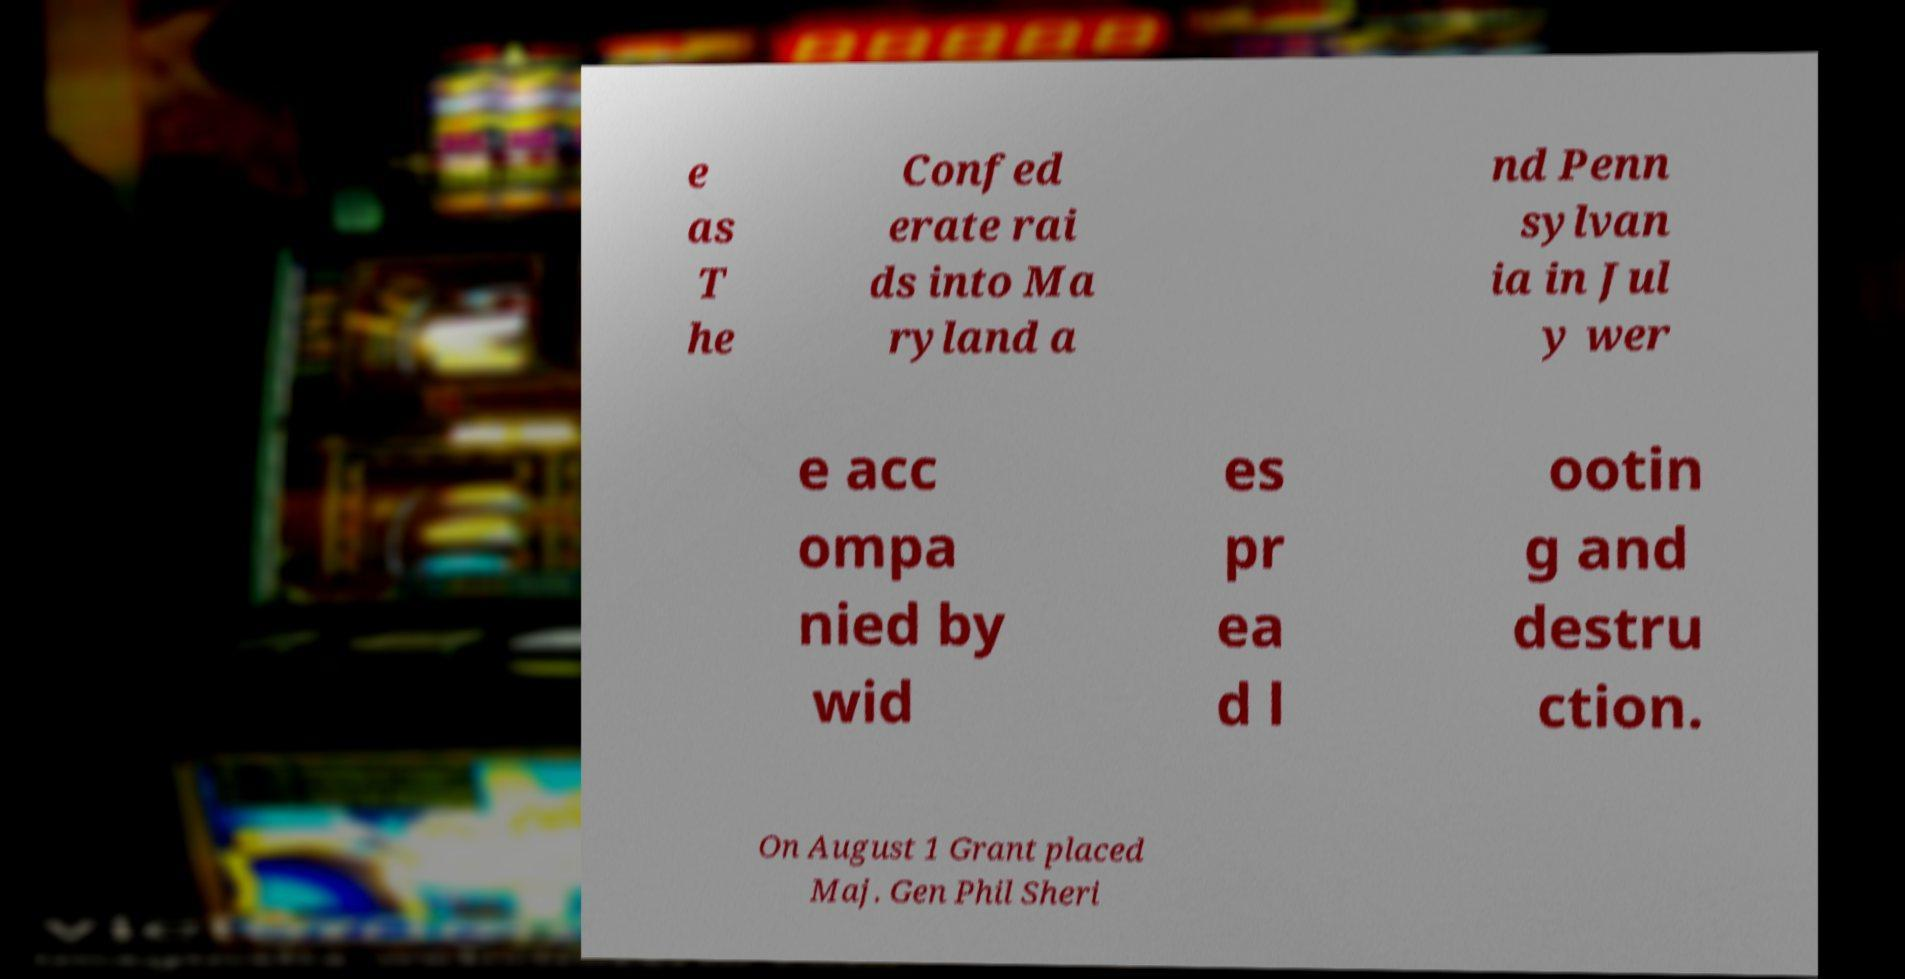For documentation purposes, I need the text within this image transcribed. Could you provide that? e as T he Confed erate rai ds into Ma ryland a nd Penn sylvan ia in Jul y wer e acc ompa nied by wid es pr ea d l ootin g and destru ction. On August 1 Grant placed Maj. Gen Phil Sheri 